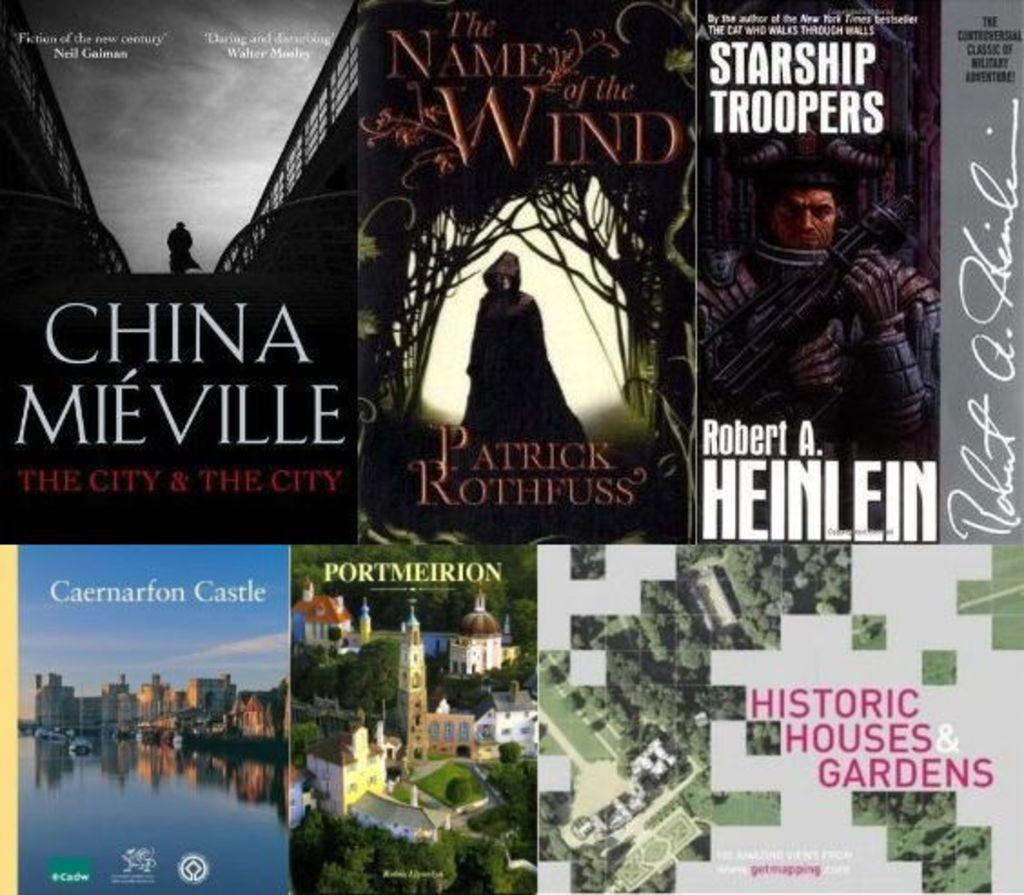<image>
Summarize the visual content of the image. the covers of several books, including The name of the wind are laying out together 